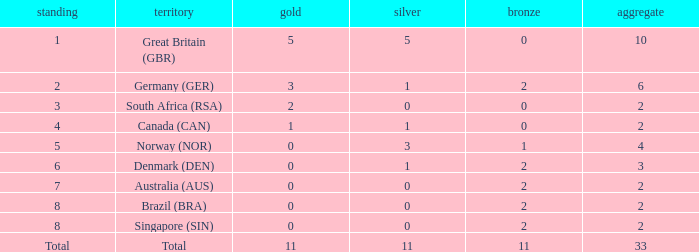What is bronze when the rank is 3 and the total is more than 2? None. 